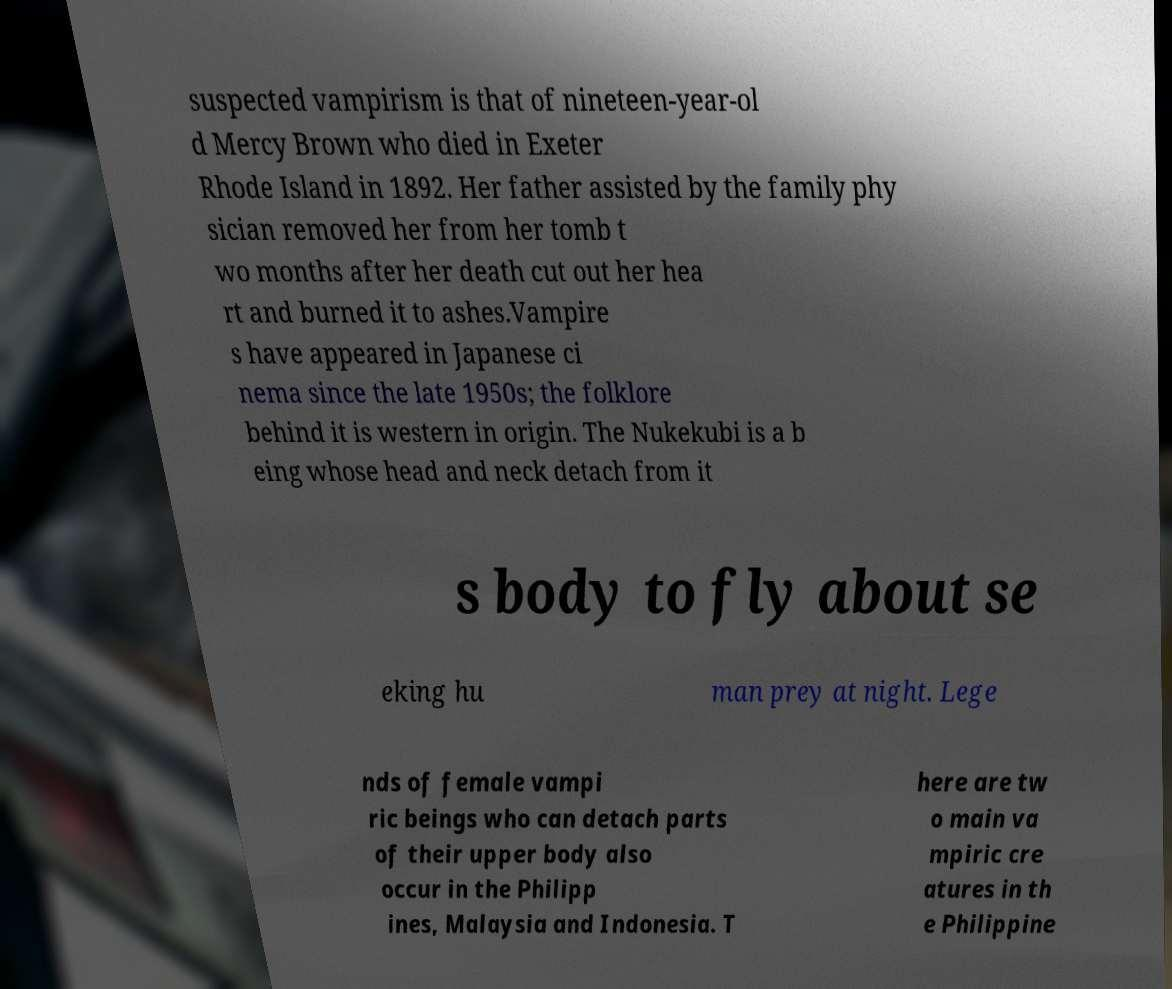For documentation purposes, I need the text within this image transcribed. Could you provide that? suspected vampirism is that of nineteen-year-ol d Mercy Brown who died in Exeter Rhode Island in 1892. Her father assisted by the family phy sician removed her from her tomb t wo months after her death cut out her hea rt and burned it to ashes.Vampire s have appeared in Japanese ci nema since the late 1950s; the folklore behind it is western in origin. The Nukekubi is a b eing whose head and neck detach from it s body to fly about se eking hu man prey at night. Lege nds of female vampi ric beings who can detach parts of their upper body also occur in the Philipp ines, Malaysia and Indonesia. T here are tw o main va mpiric cre atures in th e Philippine 